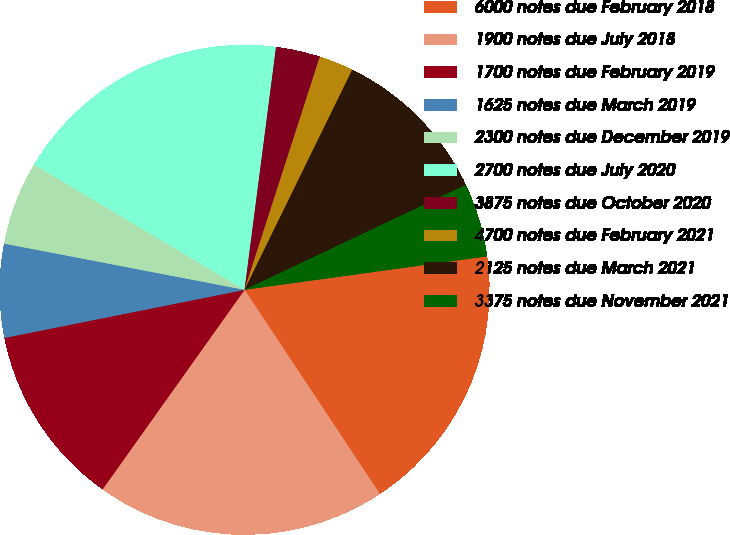Convert chart to OTSL. <chart><loc_0><loc_0><loc_500><loc_500><pie_chart><fcel>6000 notes due February 2018<fcel>1900 notes due July 2018<fcel>1700 notes due February 2019<fcel>1625 notes due March 2019<fcel>2300 notes due December 2019<fcel>2700 notes due July 2020<fcel>3875 notes due October 2020<fcel>4700 notes due February 2021<fcel>2125 notes due March 2021<fcel>3375 notes due November 2021<nl><fcel>17.86%<fcel>19.16%<fcel>12.01%<fcel>6.17%<fcel>5.52%<fcel>18.51%<fcel>2.92%<fcel>2.27%<fcel>10.71%<fcel>4.87%<nl></chart> 